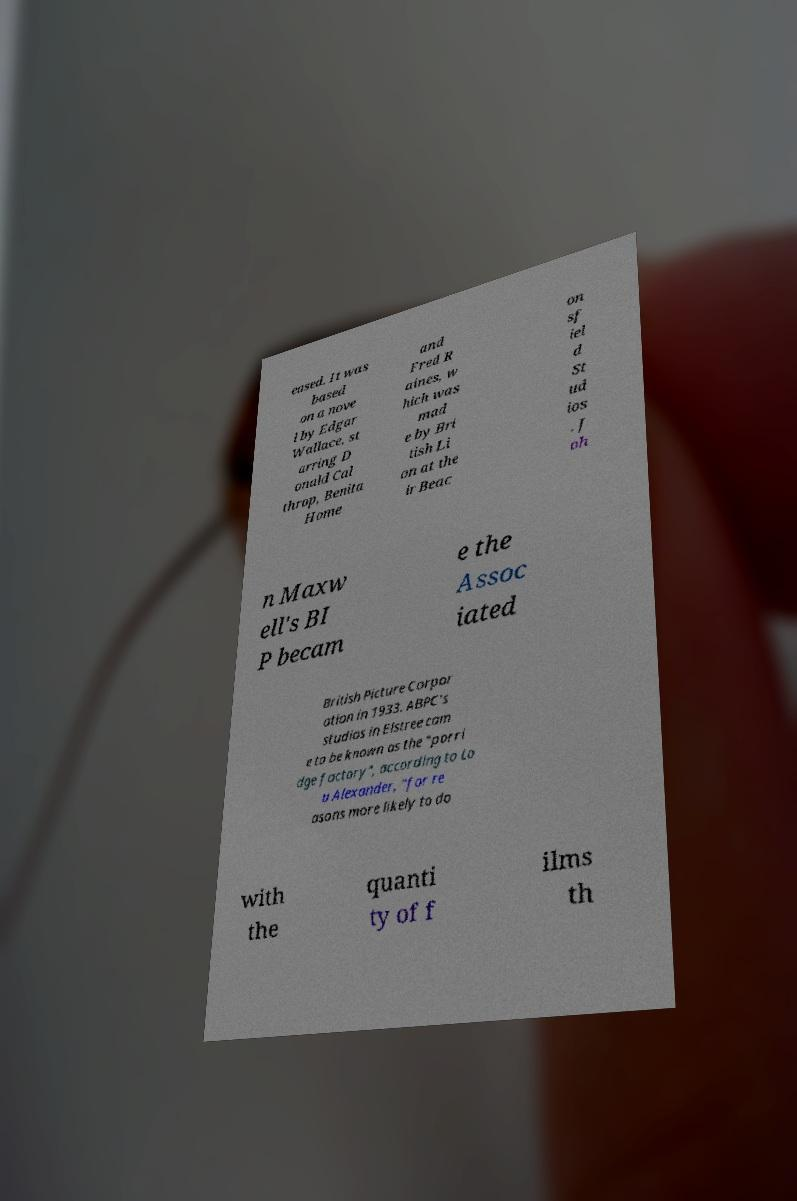Could you extract and type out the text from this image? eased. It was based on a nove l by Edgar Wallace, st arring D onald Cal throp, Benita Home and Fred R aines, w hich was mad e by Bri tish Li on at the ir Beac on sf iel d St ud ios . J oh n Maxw ell's BI P becam e the Assoc iated British Picture Corpor ation in 1933. ABPC's studios in Elstree cam e to be known as the "porri dge factory", according to Lo u Alexander, "for re asons more likely to do with the quanti ty of f ilms th 